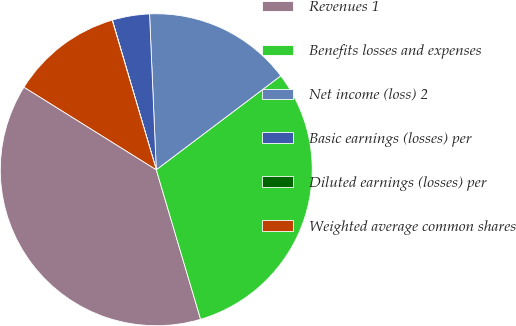Convert chart. <chart><loc_0><loc_0><loc_500><loc_500><pie_chart><fcel>Revenues 1<fcel>Benefits losses and expenses<fcel>Net income (loss) 2<fcel>Basic earnings (losses) per<fcel>Diluted earnings (losses) per<fcel>Weighted average common shares<nl><fcel>38.47%<fcel>30.7%<fcel>15.4%<fcel>3.86%<fcel>0.02%<fcel>11.55%<nl></chart> 